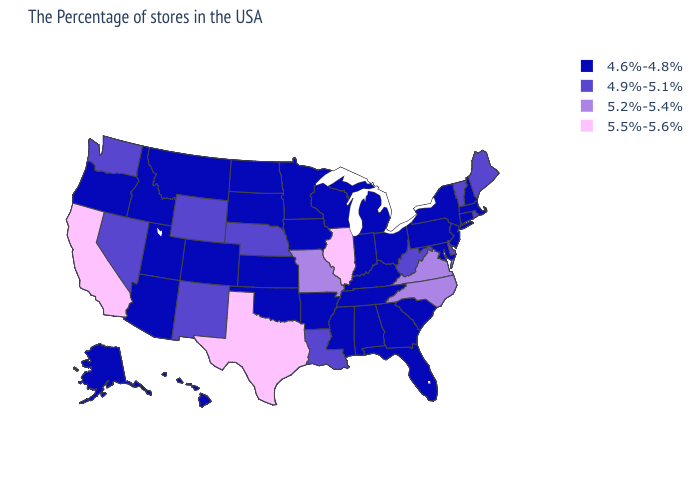Among the states that border Alabama , which have the highest value?
Write a very short answer. Florida, Georgia, Tennessee, Mississippi. Does New Mexico have the same value as Wyoming?
Short answer required. Yes. How many symbols are there in the legend?
Short answer required. 4. Does Delaware have a lower value than Missouri?
Concise answer only. Yes. How many symbols are there in the legend?
Concise answer only. 4. Which states have the highest value in the USA?
Write a very short answer. Illinois, Texas, California. Does Wyoming have the lowest value in the USA?
Be succinct. No. Name the states that have a value in the range 4.6%-4.8%?
Quick response, please. Massachusetts, New Hampshire, Connecticut, New York, New Jersey, Maryland, Pennsylvania, South Carolina, Ohio, Florida, Georgia, Michigan, Kentucky, Indiana, Alabama, Tennessee, Wisconsin, Mississippi, Arkansas, Minnesota, Iowa, Kansas, Oklahoma, South Dakota, North Dakota, Colorado, Utah, Montana, Arizona, Idaho, Oregon, Alaska, Hawaii. What is the value of Louisiana?
Write a very short answer. 4.9%-5.1%. Name the states that have a value in the range 4.6%-4.8%?
Give a very brief answer. Massachusetts, New Hampshire, Connecticut, New York, New Jersey, Maryland, Pennsylvania, South Carolina, Ohio, Florida, Georgia, Michigan, Kentucky, Indiana, Alabama, Tennessee, Wisconsin, Mississippi, Arkansas, Minnesota, Iowa, Kansas, Oklahoma, South Dakota, North Dakota, Colorado, Utah, Montana, Arizona, Idaho, Oregon, Alaska, Hawaii. Name the states that have a value in the range 5.5%-5.6%?
Concise answer only. Illinois, Texas, California. What is the lowest value in the USA?
Quick response, please. 4.6%-4.8%. Name the states that have a value in the range 5.2%-5.4%?
Answer briefly. Virginia, North Carolina, Missouri. Which states have the lowest value in the MidWest?
Concise answer only. Ohio, Michigan, Indiana, Wisconsin, Minnesota, Iowa, Kansas, South Dakota, North Dakota. 